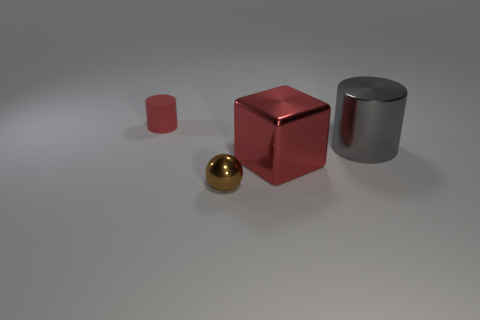What might be the purpose of this arrangement of objects? This arrangement of objects might serve several purposes. It could be a simplistic still-life study focusing on geometry, color, and reflections — often used by 3D artists to demonstrate rendering techniques. Alternatively, this could be an illustrative setup for educational purposes, showcasing different shapes and materials, or part of a visual composition in a larger artistic or commercial project. 